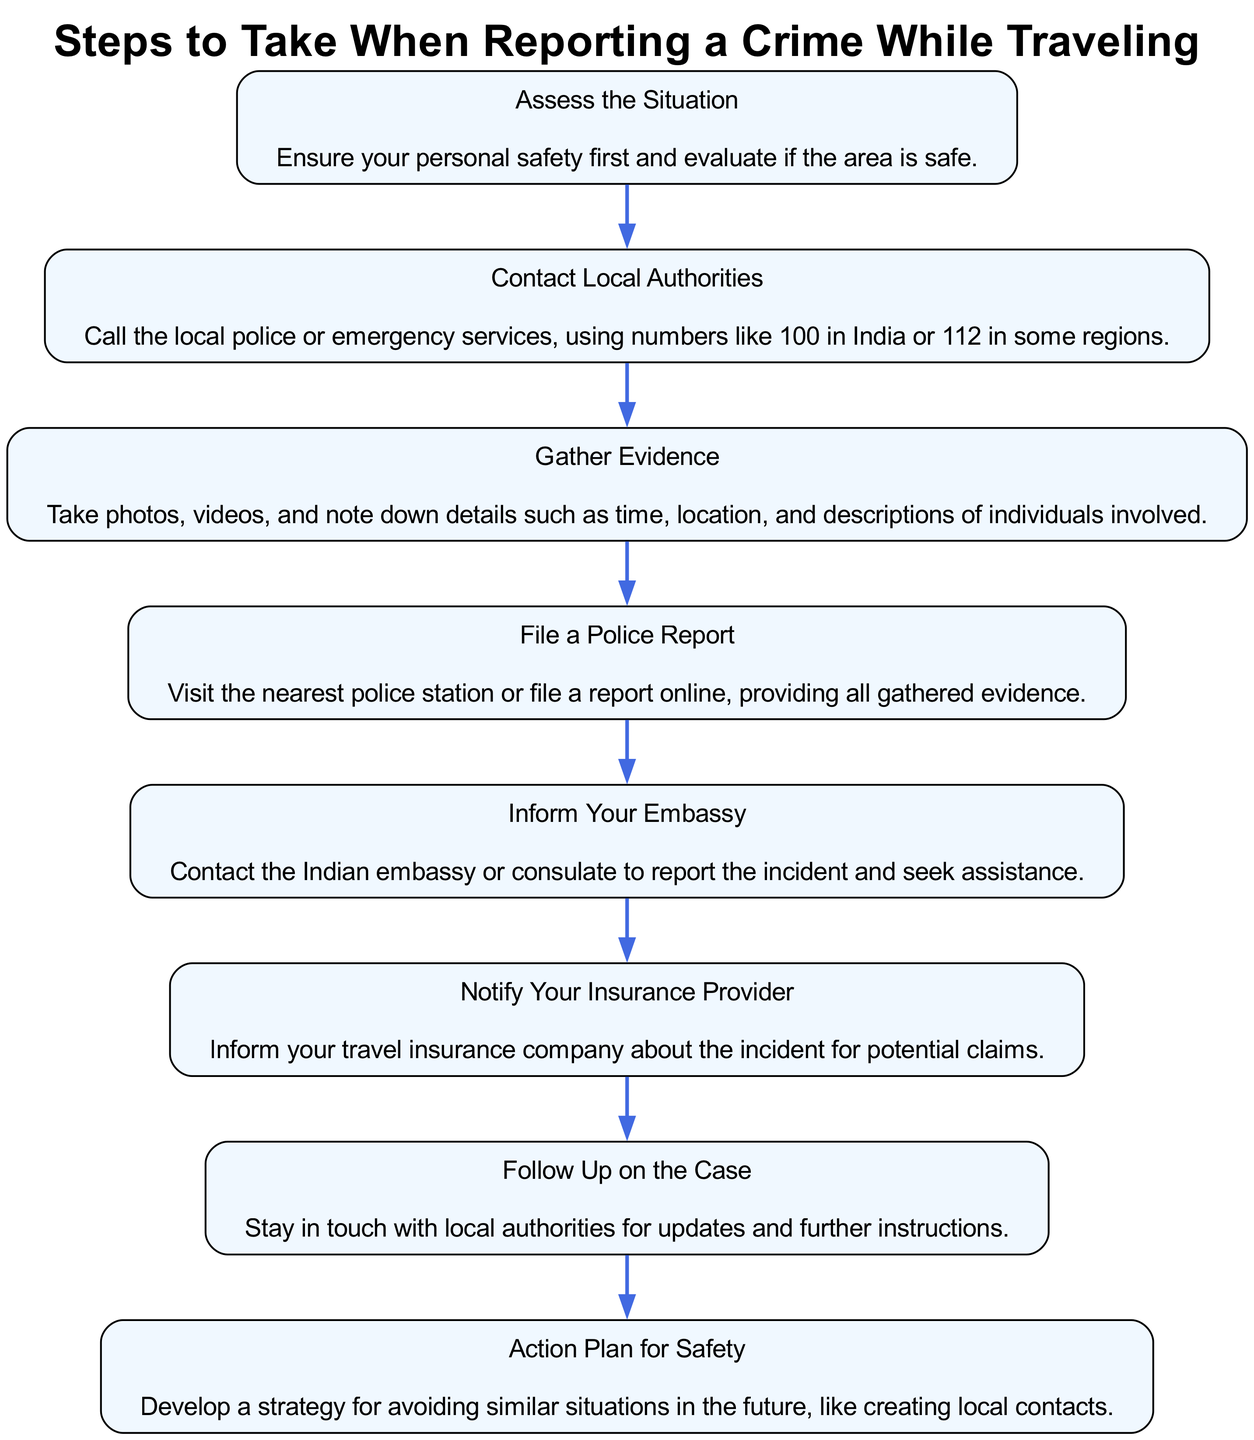What is the first step listed in the diagram? The first step according to the diagram is "Assess the Situation". This information can be found at the start of the flow, indicating the initial action to take.
Answer: Assess the Situation How many steps are there in total in the diagram? To find the total number of steps, we can count each node represented in the diagram. There are 8 distinct steps listed.
Answer: 8 What is the last step in the sequence? The last step in the flow is "Action Plan for Safety". This is clearly positioned at the end, indicating the final action to take after reporting the crime.
Answer: Action Plan for Safety Which step comes immediately after "Gather Evidence"? After "Gather Evidence", the next step is "File a Police Report". This relationship is indicated by the direct connection leading from the "Gather Evidence" node to the "File a Police Report" node.
Answer: File a Police Report What two steps appear directly before 'Inform Your Embassy'? The two steps that come before "Inform Your Embassy" are "File a Police Report" and "Gather Evidence". This can be understood by following the flow leading to "Inform Your Embassy".
Answer: File a Police Report, Gather Evidence What should you do after notifying your insurance provider? The step following the notification to your insurance provider is "Follow Up on the Case". This shows the next action one should take after that specific notification.
Answer: Follow Up on the Case Is "Contact Local Authorities" the second step in the sequence? Yes, "Contact Local Authorities" is indeed the second step. If we check the order of the steps, it is placed second in the flow after the first step, "Assess the Situation."
Answer: Yes Which step emphasizes personal safety first? The step that emphasizes personal safety first is "Assess the Situation". This is explicitly stated as the initial step in the diagram.
Answer: Assess the Situation 